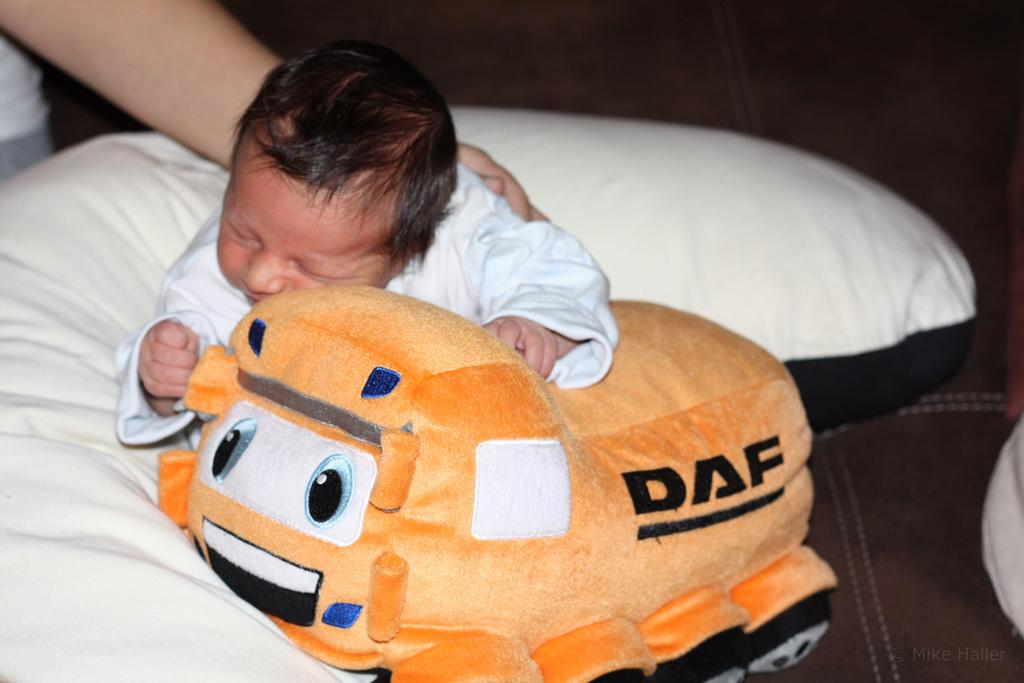What is the main subject of the image? There is a baby in the image. What is the baby lying on in the image? There is a bed in the image. What is placed on the bed with the baby? There is a pillow on the bed in the image. Who else is present in the image besides the baby? There is a person in the image. What type of activity is the baby participating in at the market in the image? There is no market present in the image, and the baby is not participating in any activity. 